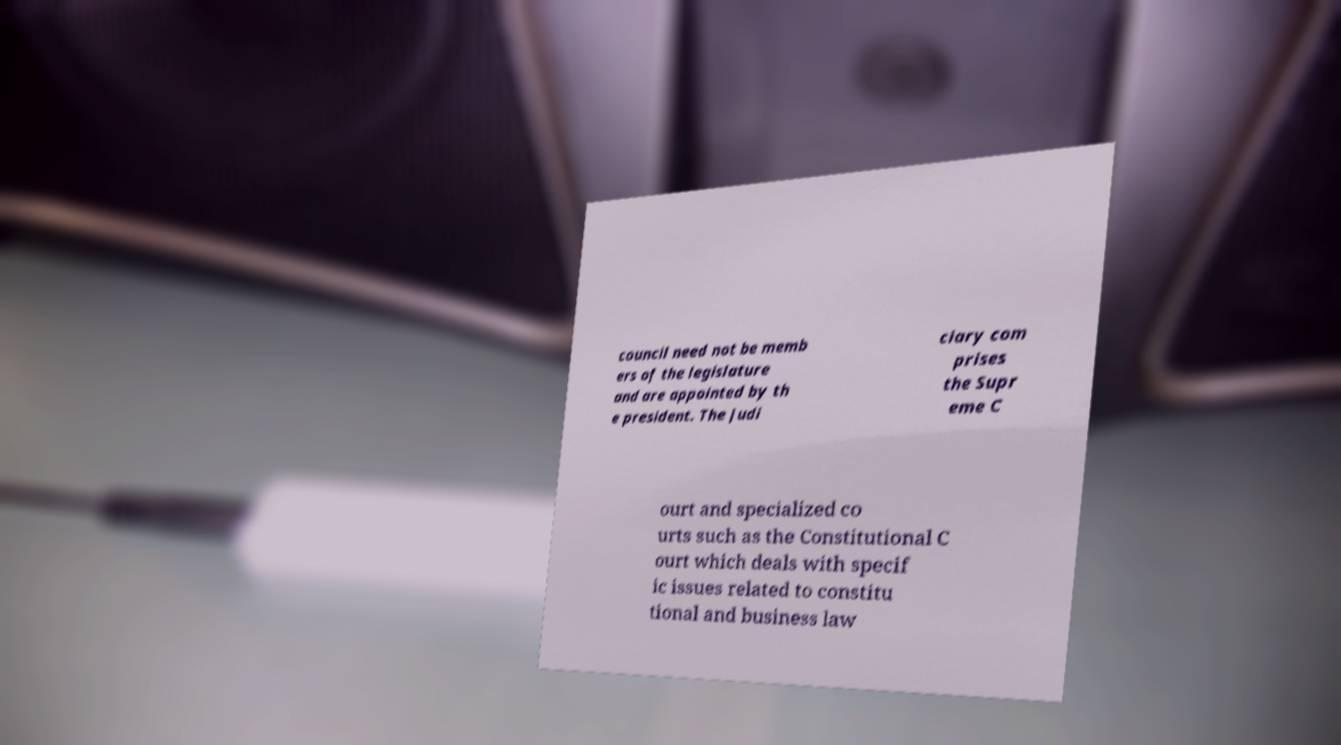Could you assist in decoding the text presented in this image and type it out clearly? council need not be memb ers of the legislature and are appointed by th e president. The judi ciary com prises the Supr eme C ourt and specialized co urts such as the Constitutional C ourt which deals with specif ic issues related to constitu tional and business law 